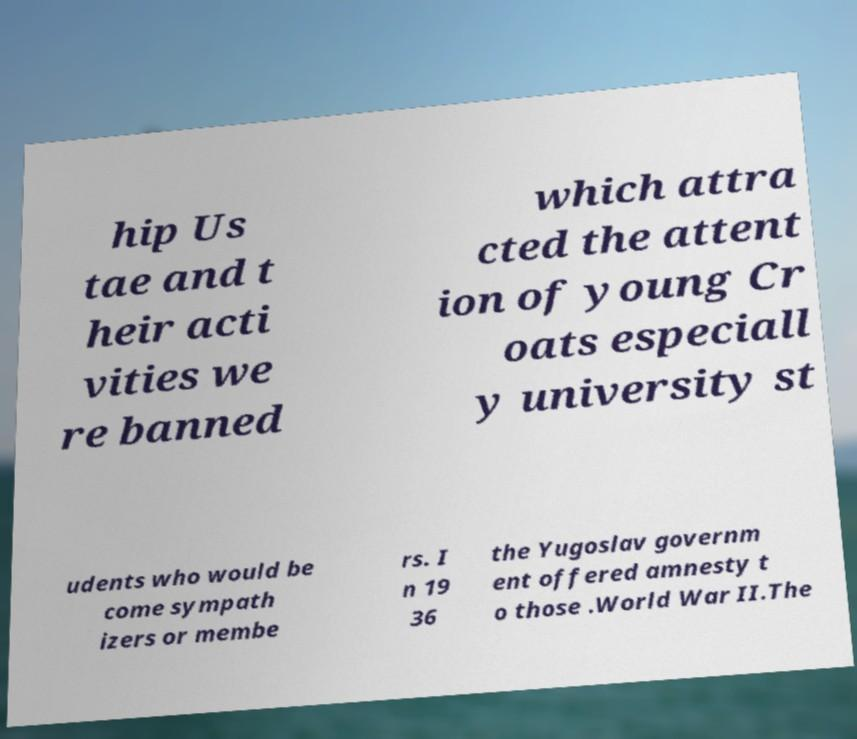Could you assist in decoding the text presented in this image and type it out clearly? hip Us tae and t heir acti vities we re banned which attra cted the attent ion of young Cr oats especiall y university st udents who would be come sympath izers or membe rs. I n 19 36 the Yugoslav governm ent offered amnesty t o those .World War II.The 